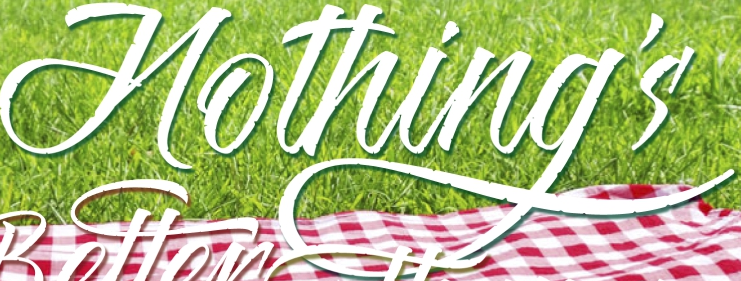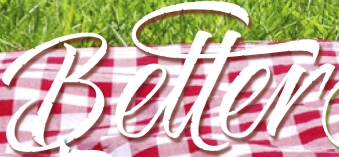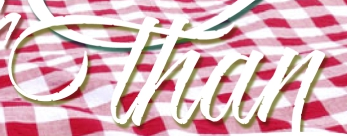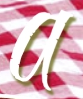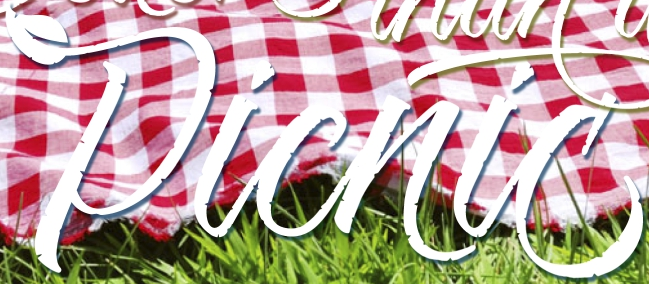What words can you see in these images in sequence, separated by a semicolon? Hothing's; Better; than; a; Picnic 